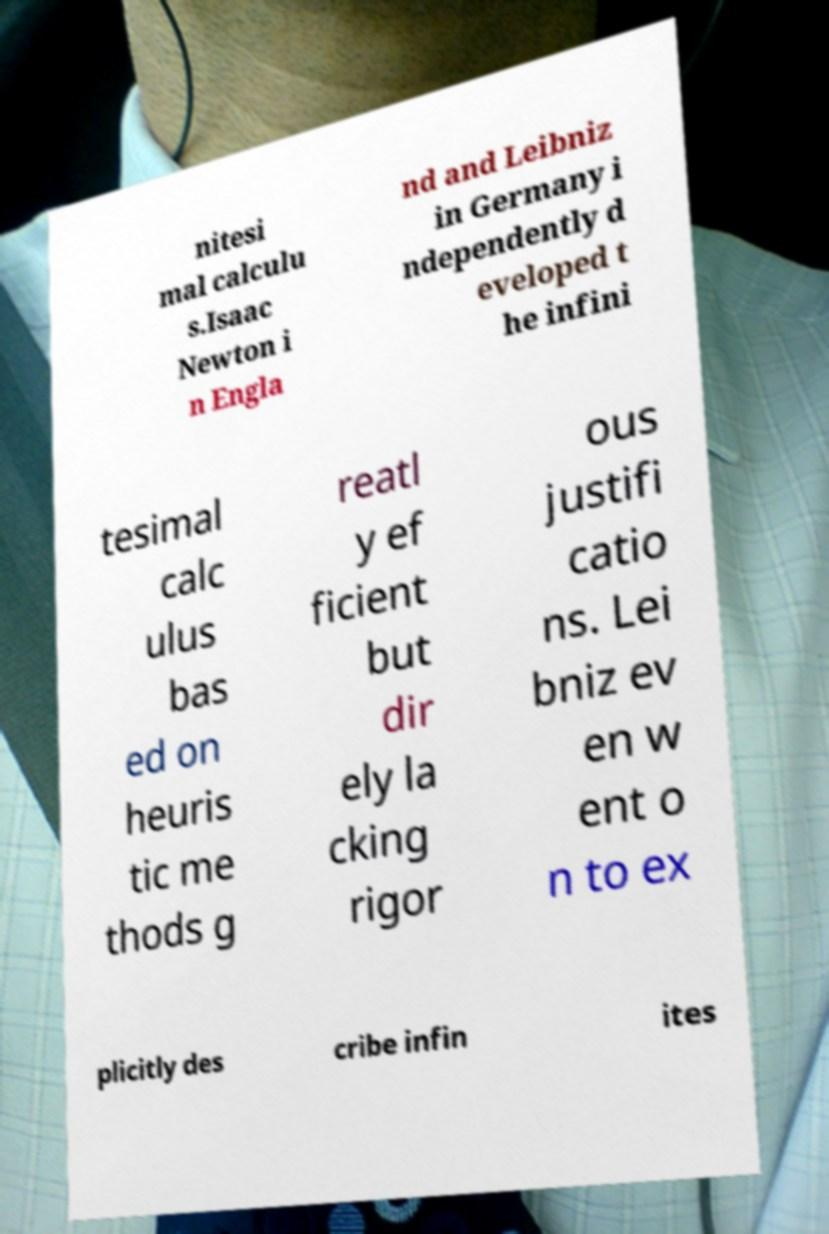Can you accurately transcribe the text from the provided image for me? nitesi mal calculu s.Isaac Newton i n Engla nd and Leibniz in Germany i ndependently d eveloped t he infini tesimal calc ulus bas ed on heuris tic me thods g reatl y ef ficient but dir ely la cking rigor ous justifi catio ns. Lei bniz ev en w ent o n to ex plicitly des cribe infin ites 